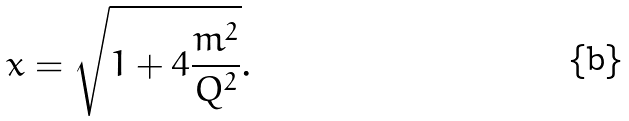<formula> <loc_0><loc_0><loc_500><loc_500>x = \sqrt { 1 + 4 \frac { m ^ { 2 } } { Q ^ { 2 } } } .</formula> 